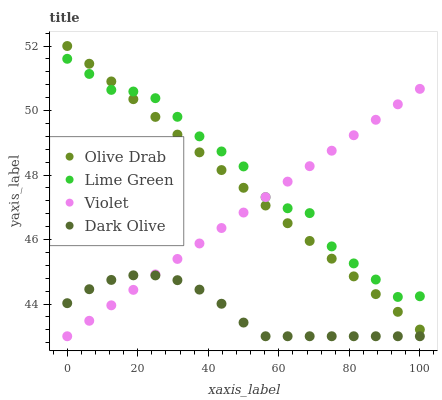Does Dark Olive have the minimum area under the curve?
Answer yes or no. Yes. Does Lime Green have the maximum area under the curve?
Answer yes or no. Yes. Does Olive Drab have the minimum area under the curve?
Answer yes or no. No. Does Olive Drab have the maximum area under the curve?
Answer yes or no. No. Is Olive Drab the smoothest?
Answer yes or no. Yes. Is Lime Green the roughest?
Answer yes or no. Yes. Is Lime Green the smoothest?
Answer yes or no. No. Is Olive Drab the roughest?
Answer yes or no. No. Does Dark Olive have the lowest value?
Answer yes or no. Yes. Does Olive Drab have the lowest value?
Answer yes or no. No. Does Olive Drab have the highest value?
Answer yes or no. Yes. Does Lime Green have the highest value?
Answer yes or no. No. Is Dark Olive less than Olive Drab?
Answer yes or no. Yes. Is Lime Green greater than Dark Olive?
Answer yes or no. Yes. Does Lime Green intersect Olive Drab?
Answer yes or no. Yes. Is Lime Green less than Olive Drab?
Answer yes or no. No. Is Lime Green greater than Olive Drab?
Answer yes or no. No. Does Dark Olive intersect Olive Drab?
Answer yes or no. No. 